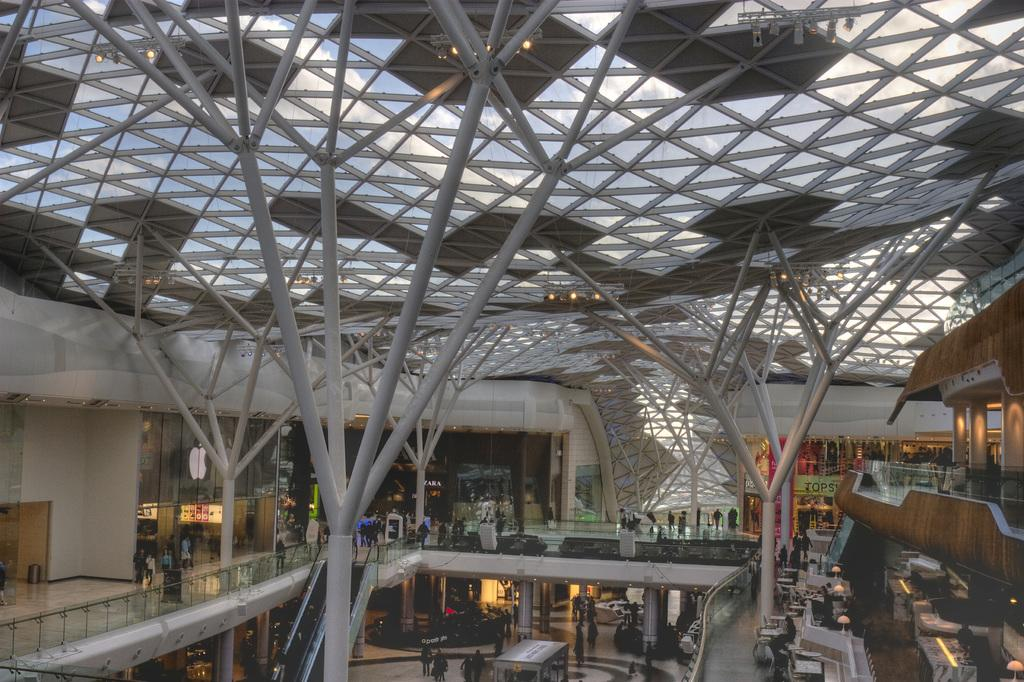What type of location is depicted in the image? The image shows an inside view of a building. What can be seen on the floor in the image? There are people on the floor in the image. What architectural feature is visible in the image? There are pillars visible in the image. What part of the building can be seen in the image? The roof is visible in the image. What is providing illumination in the image? There are lights in the image. What else is present in the image besides people and lights? There are objects present in the image. What type of toothpaste is being used by the people in the image? There is no toothpaste present in the image; it depicts an inside view of a building with people and objects. What kind of veil is draped over the pillars in the image? There is no veil present in the image; it only shows pillars and other architectural features. 